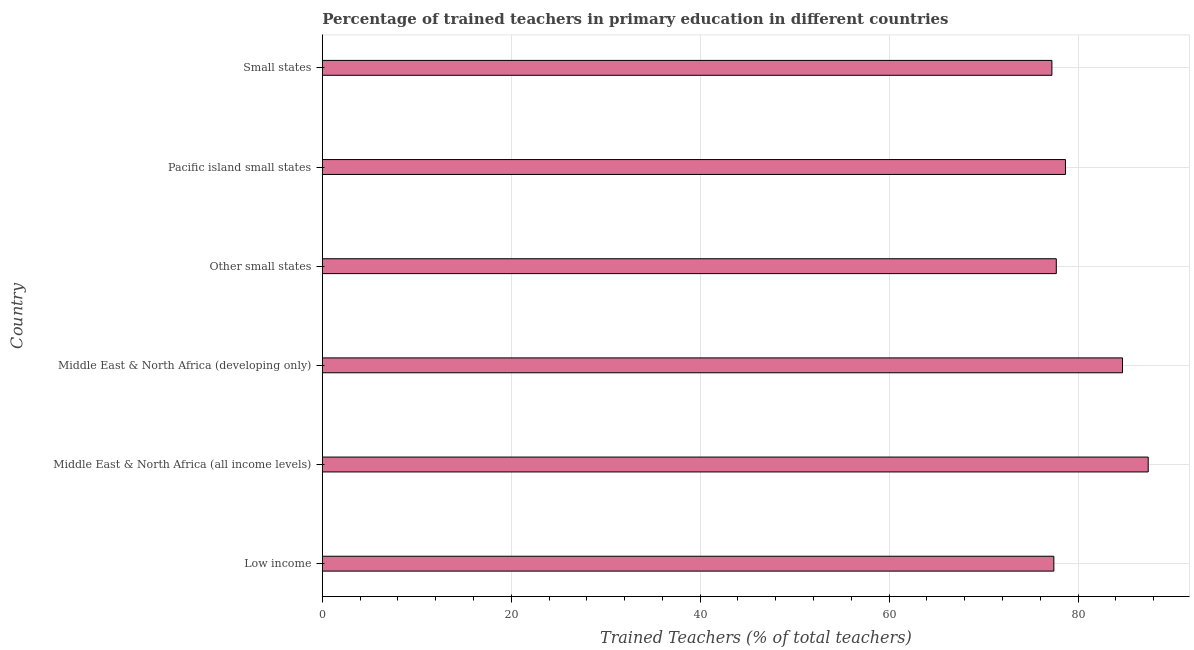Does the graph contain any zero values?
Make the answer very short. No. What is the title of the graph?
Make the answer very short. Percentage of trained teachers in primary education in different countries. What is the label or title of the X-axis?
Keep it short and to the point. Trained Teachers (% of total teachers). What is the percentage of trained teachers in Other small states?
Make the answer very short. 77.7. Across all countries, what is the maximum percentage of trained teachers?
Your response must be concise. 87.43. Across all countries, what is the minimum percentage of trained teachers?
Give a very brief answer. 77.23. In which country was the percentage of trained teachers maximum?
Your answer should be very brief. Middle East & North Africa (all income levels). In which country was the percentage of trained teachers minimum?
Keep it short and to the point. Small states. What is the sum of the percentage of trained teachers?
Make the answer very short. 483.17. What is the difference between the percentage of trained teachers in Middle East & North Africa (all income levels) and Small states?
Offer a terse response. 10.19. What is the average percentage of trained teachers per country?
Ensure brevity in your answer.  80.53. What is the median percentage of trained teachers?
Your answer should be compact. 78.18. In how many countries, is the percentage of trained teachers greater than 24 %?
Keep it short and to the point. 6. Is the difference between the percentage of trained teachers in Middle East & North Africa (all income levels) and Pacific island small states greater than the difference between any two countries?
Offer a very short reply. No. What is the difference between the highest and the second highest percentage of trained teachers?
Your response must be concise. 2.72. Is the sum of the percentage of trained teachers in Middle East & North Africa (developing only) and Pacific island small states greater than the maximum percentage of trained teachers across all countries?
Make the answer very short. Yes. What is the difference between the highest and the lowest percentage of trained teachers?
Your response must be concise. 10.19. In how many countries, is the percentage of trained teachers greater than the average percentage of trained teachers taken over all countries?
Keep it short and to the point. 2. Are the values on the major ticks of X-axis written in scientific E-notation?
Offer a terse response. No. What is the Trained Teachers (% of total teachers) in Low income?
Offer a terse response. 77.44. What is the Trained Teachers (% of total teachers) of Middle East & North Africa (all income levels)?
Provide a succinct answer. 87.43. What is the Trained Teachers (% of total teachers) of Middle East & North Africa (developing only)?
Make the answer very short. 84.71. What is the Trained Teachers (% of total teachers) in Other small states?
Keep it short and to the point. 77.7. What is the Trained Teachers (% of total teachers) of Pacific island small states?
Make the answer very short. 78.67. What is the Trained Teachers (% of total teachers) in Small states?
Offer a terse response. 77.23. What is the difference between the Trained Teachers (% of total teachers) in Low income and Middle East & North Africa (all income levels)?
Offer a terse response. -9.99. What is the difference between the Trained Teachers (% of total teachers) in Low income and Middle East & North Africa (developing only)?
Provide a succinct answer. -7.27. What is the difference between the Trained Teachers (% of total teachers) in Low income and Other small states?
Your answer should be very brief. -0.26. What is the difference between the Trained Teachers (% of total teachers) in Low income and Pacific island small states?
Keep it short and to the point. -1.23. What is the difference between the Trained Teachers (% of total teachers) in Low income and Small states?
Make the answer very short. 0.21. What is the difference between the Trained Teachers (% of total teachers) in Middle East & North Africa (all income levels) and Middle East & North Africa (developing only)?
Your answer should be compact. 2.72. What is the difference between the Trained Teachers (% of total teachers) in Middle East & North Africa (all income levels) and Other small states?
Your answer should be compact. 9.73. What is the difference between the Trained Teachers (% of total teachers) in Middle East & North Africa (all income levels) and Pacific island small states?
Offer a very short reply. 8.76. What is the difference between the Trained Teachers (% of total teachers) in Middle East & North Africa (all income levels) and Small states?
Your answer should be very brief. 10.19. What is the difference between the Trained Teachers (% of total teachers) in Middle East & North Africa (developing only) and Other small states?
Make the answer very short. 7.01. What is the difference between the Trained Teachers (% of total teachers) in Middle East & North Africa (developing only) and Pacific island small states?
Your response must be concise. 6.04. What is the difference between the Trained Teachers (% of total teachers) in Middle East & North Africa (developing only) and Small states?
Your answer should be very brief. 7.47. What is the difference between the Trained Teachers (% of total teachers) in Other small states and Pacific island small states?
Provide a succinct answer. -0.97. What is the difference between the Trained Teachers (% of total teachers) in Other small states and Small states?
Provide a short and direct response. 0.46. What is the difference between the Trained Teachers (% of total teachers) in Pacific island small states and Small states?
Your answer should be compact. 1.44. What is the ratio of the Trained Teachers (% of total teachers) in Low income to that in Middle East & North Africa (all income levels)?
Ensure brevity in your answer.  0.89. What is the ratio of the Trained Teachers (% of total teachers) in Low income to that in Middle East & North Africa (developing only)?
Offer a very short reply. 0.91. What is the ratio of the Trained Teachers (% of total teachers) in Low income to that in Other small states?
Your response must be concise. 1. What is the ratio of the Trained Teachers (% of total teachers) in Low income to that in Pacific island small states?
Offer a terse response. 0.98. What is the ratio of the Trained Teachers (% of total teachers) in Low income to that in Small states?
Your answer should be compact. 1. What is the ratio of the Trained Teachers (% of total teachers) in Middle East & North Africa (all income levels) to that in Middle East & North Africa (developing only)?
Keep it short and to the point. 1.03. What is the ratio of the Trained Teachers (% of total teachers) in Middle East & North Africa (all income levels) to that in Pacific island small states?
Provide a succinct answer. 1.11. What is the ratio of the Trained Teachers (% of total teachers) in Middle East & North Africa (all income levels) to that in Small states?
Your answer should be compact. 1.13. What is the ratio of the Trained Teachers (% of total teachers) in Middle East & North Africa (developing only) to that in Other small states?
Offer a very short reply. 1.09. What is the ratio of the Trained Teachers (% of total teachers) in Middle East & North Africa (developing only) to that in Pacific island small states?
Your answer should be compact. 1.08. What is the ratio of the Trained Teachers (% of total teachers) in Middle East & North Africa (developing only) to that in Small states?
Keep it short and to the point. 1.1. What is the ratio of the Trained Teachers (% of total teachers) in Other small states to that in Pacific island small states?
Ensure brevity in your answer.  0.99. What is the ratio of the Trained Teachers (% of total teachers) in Pacific island small states to that in Small states?
Make the answer very short. 1.02. 